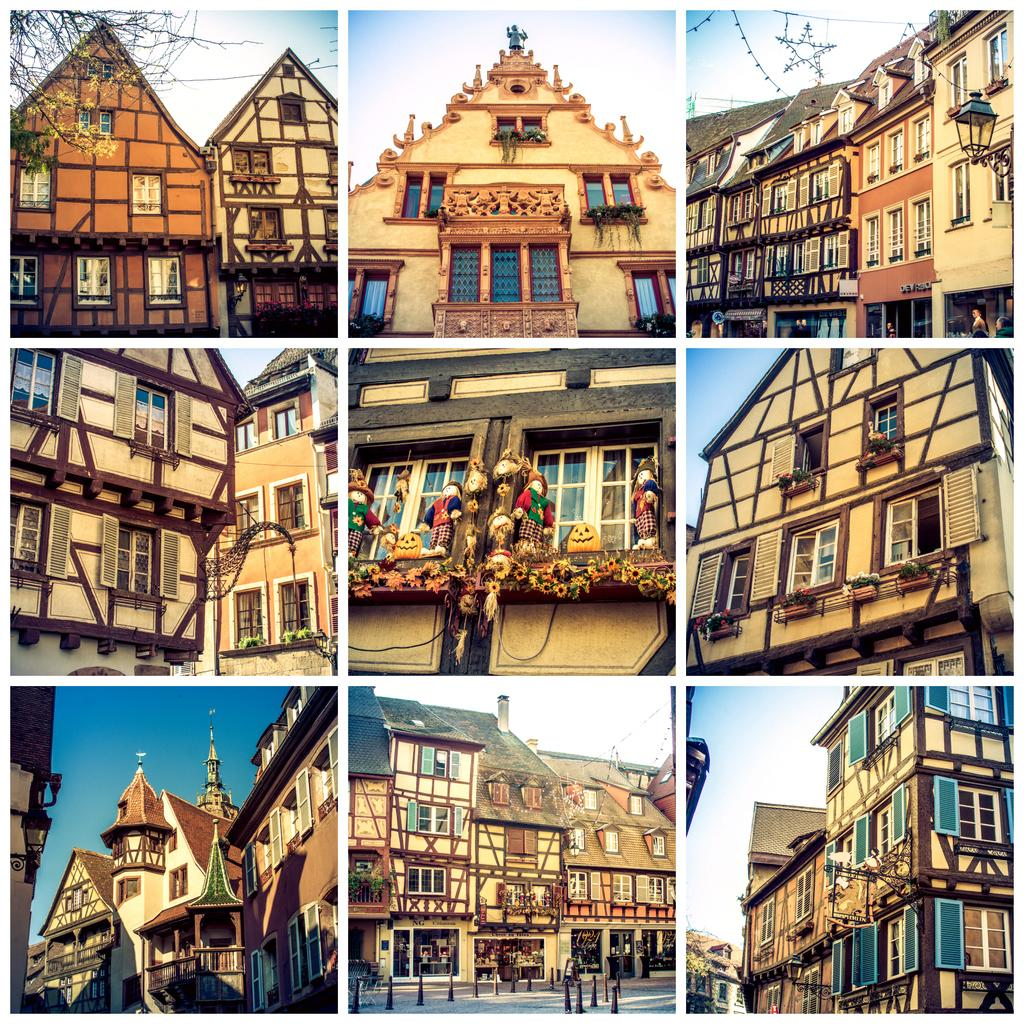What type of structures can be seen in the image? There are buildings in the image. What is attached to the wall in the image? There are toys attached to the wall in the image. What can be seen in the image that provides light? There is a light-pole in the image. What type of vegetation is present in the image? There are trees in the image. What is the color of the sky in the image? The sky is blue and white in color. What language is the stranger speaking in the image? There is no stranger present in the image, so it is not possible to determine what language they might be speaking. 